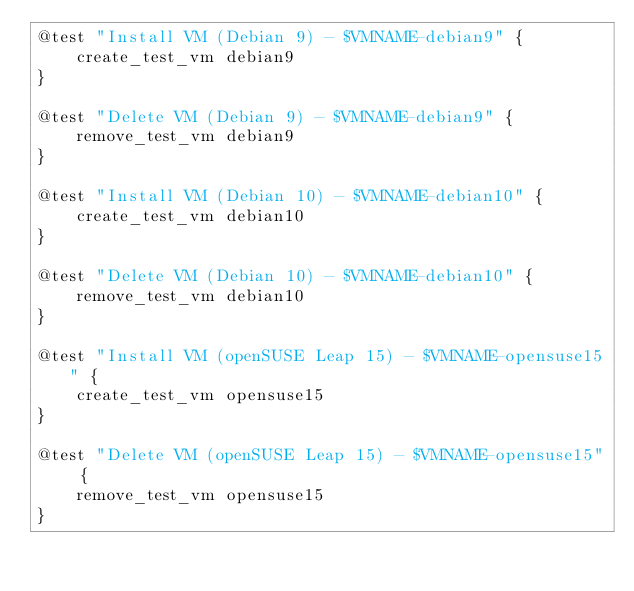<code> <loc_0><loc_0><loc_500><loc_500><_Bash_>@test "Install VM (Debian 9) - $VMNAME-debian9" {
    create_test_vm debian9
}

@test "Delete VM (Debian 9) - $VMNAME-debian9" {
    remove_test_vm debian9
}

@test "Install VM (Debian 10) - $VMNAME-debian10" {
    create_test_vm debian10
}

@test "Delete VM (Debian 10) - $VMNAME-debian10" {
    remove_test_vm debian10
}

@test "Install VM (openSUSE Leap 15) - $VMNAME-opensuse15" {
    create_test_vm opensuse15
}

@test "Delete VM (openSUSE Leap 15) - $VMNAME-opensuse15" {
    remove_test_vm opensuse15
}
</code> 